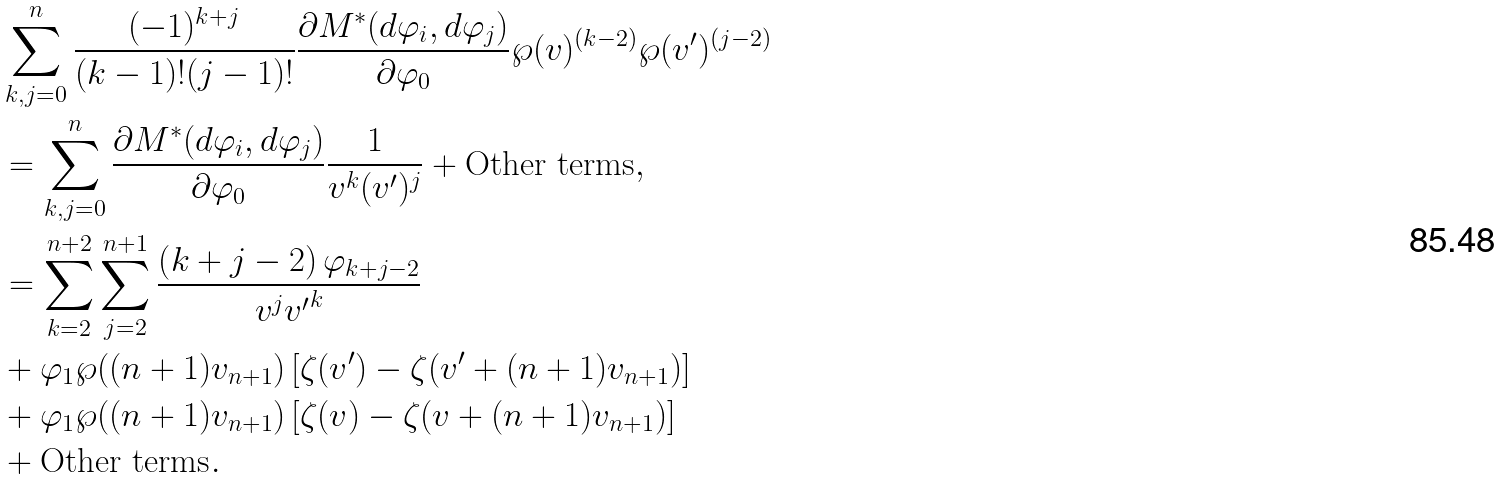<formula> <loc_0><loc_0><loc_500><loc_500>& \sum _ { k , j = 0 } ^ { n } \frac { ( - 1 ) ^ { k + j } } { ( k - 1 ) ! ( j - 1 ) ! } \frac { \partial M ^ { * } ( d \varphi _ { i } , d \varphi _ { j } ) } { \partial \varphi _ { 0 } } \wp ( v ) ^ { ( k - 2 ) } \wp ( v ^ { \prime } ) ^ { ( j - 2 ) } \\ & = \sum _ { k , j = 0 } ^ { n } \frac { \partial M ^ { * } ( d \varphi _ { i } , d \varphi _ { j } ) } { \partial \varphi _ { 0 } } \frac { 1 } { v ^ { k } ( v ^ { \prime } ) ^ { j } } + \text {Other terms} , \\ & = \sum _ { k = 2 } ^ { n + 2 } \sum _ { j = 2 } ^ { n + 1 } \frac { \left ( k + j - 2 \right ) \varphi _ { k + j - 2 } } { v ^ { j } { v ^ { \prime } } ^ { k } } \\ & + \varphi _ { 1 } \wp ( ( n + 1 ) v _ { n + 1 } ) \left [ \zeta ( v ^ { \prime } ) - \zeta ( v ^ { \prime } + ( n + 1 ) v _ { n + 1 } ) \right ] \\ & + \varphi _ { 1 } \wp ( ( n + 1 ) v _ { n + 1 } ) \left [ \zeta ( v ) - \zeta ( v + ( n + 1 ) v _ { n + 1 } ) \right ] \\ & + \text {Other terms} . \\</formula> 